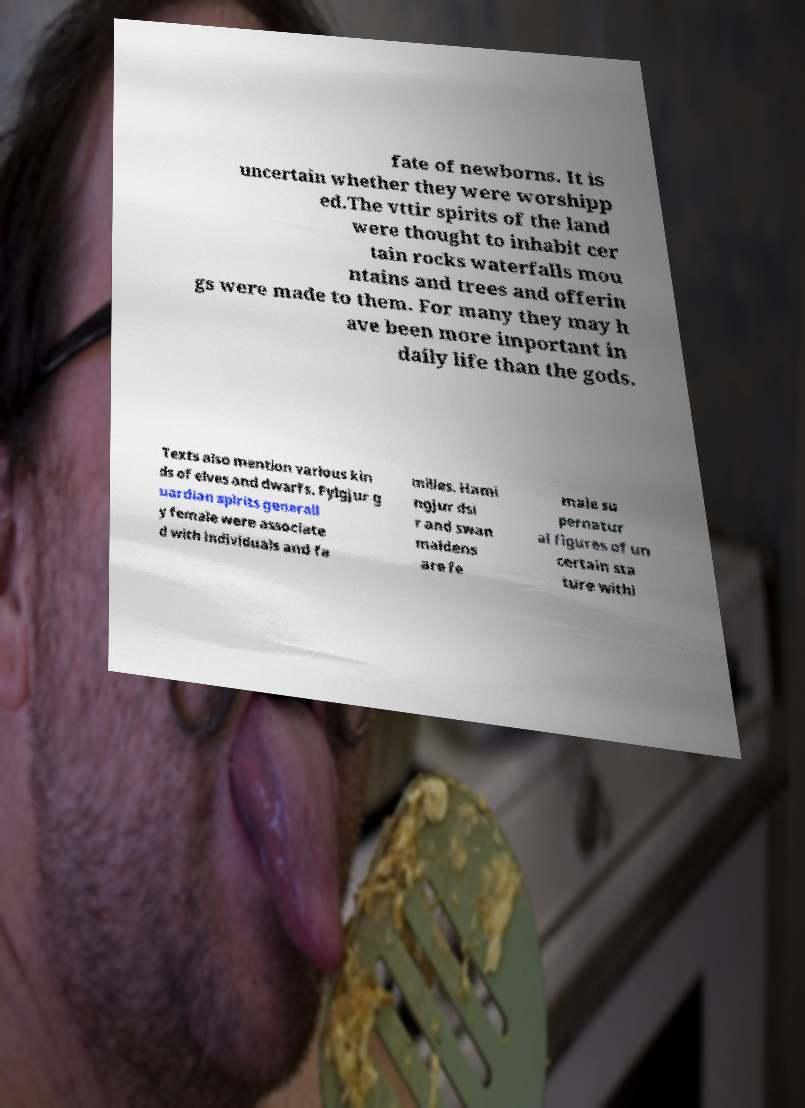Can you accurately transcribe the text from the provided image for me? fate of newborns. It is uncertain whether they were worshipp ed.The vttir spirits of the land were thought to inhabit cer tain rocks waterfalls mou ntains and trees and offerin gs were made to them. For many they may h ave been more important in daily life than the gods. Texts also mention various kin ds of elves and dwarfs. Fylgjur g uardian spirits generall y female were associate d with individuals and fa milies. Hami ngjur dsi r and swan maidens are fe male su pernatur al figures of un certain sta ture withi 